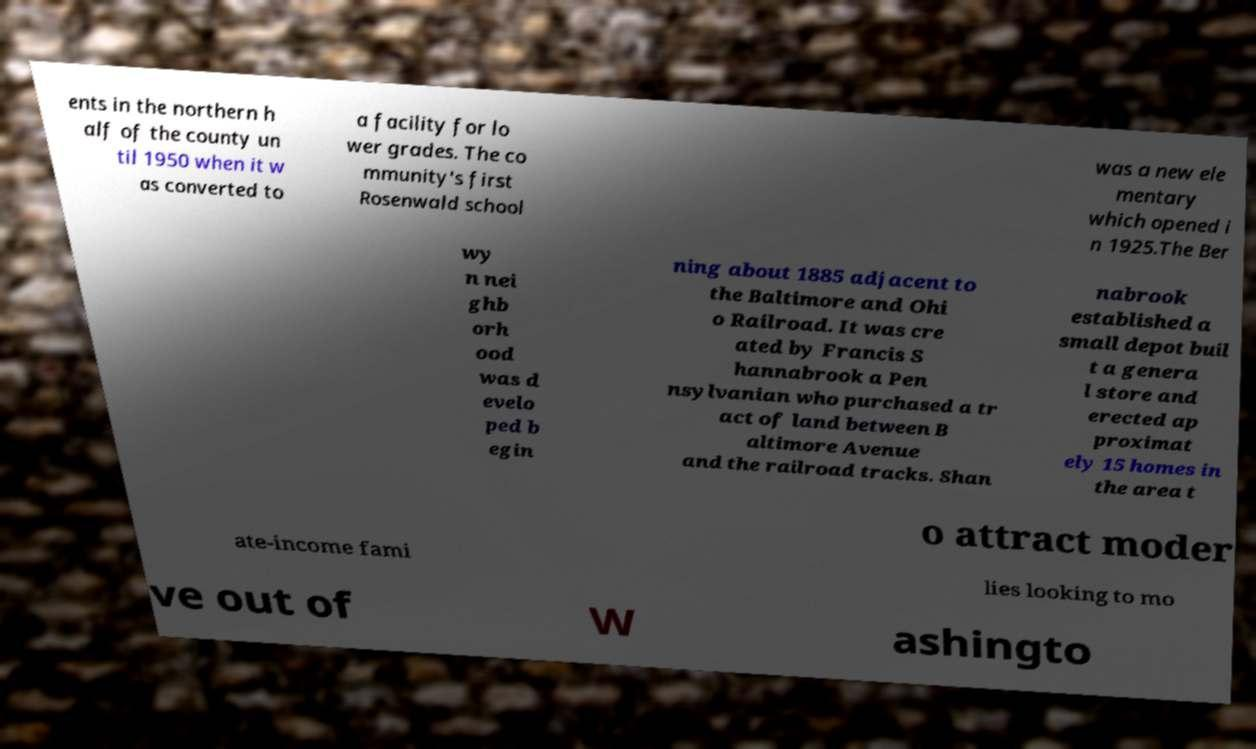Could you extract and type out the text from this image? ents in the northern h alf of the county un til 1950 when it w as converted to a facility for lo wer grades. The co mmunity's first Rosenwald school was a new ele mentary which opened i n 1925.The Ber wy n nei ghb orh ood was d evelo ped b egin ning about 1885 adjacent to the Baltimore and Ohi o Railroad. It was cre ated by Francis S hannabrook a Pen nsylvanian who purchased a tr act of land between B altimore Avenue and the railroad tracks. Shan nabrook established a small depot buil t a genera l store and erected ap proximat ely 15 homes in the area t o attract moder ate-income fami lies looking to mo ve out of W ashingto 